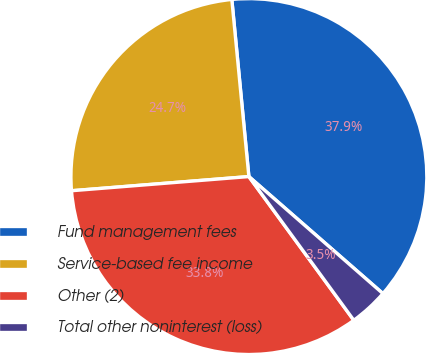<chart> <loc_0><loc_0><loc_500><loc_500><pie_chart><fcel>Fund management fees<fcel>Service-based fee income<fcel>Other (2)<fcel>Total other noninterest (loss)<nl><fcel>37.95%<fcel>24.74%<fcel>33.77%<fcel>3.54%<nl></chart> 